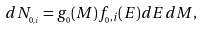<formula> <loc_0><loc_0><loc_500><loc_500>d N _ { _ { 0 , i } } = g _ { _ { 0 } } ( M ) f _ { _ { 0 } , i } ( E ) d E d M ,</formula> 